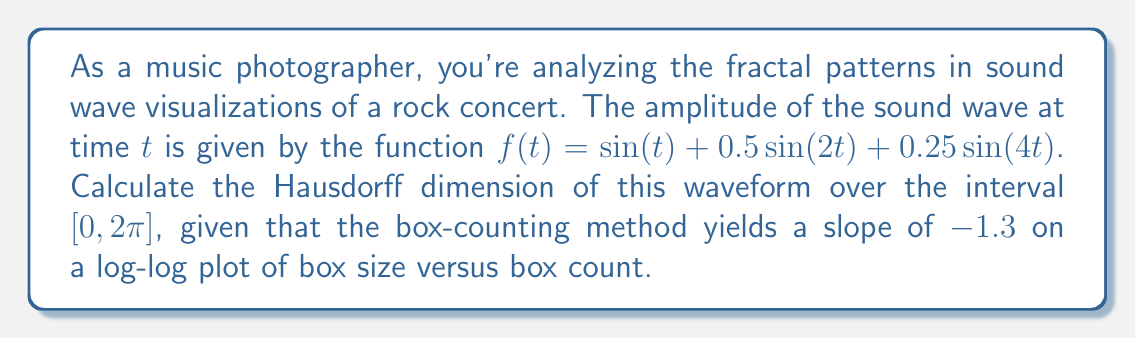What is the answer to this math problem? To determine the Hausdorff dimension of the sound wave visualization, we'll follow these steps:

1) The Hausdorff dimension is closely related to the box-counting dimension. In many cases, they are equivalent.

2) The box-counting dimension is defined as:

   $$D = -\lim_{\epsilon \to 0} \frac{\log N(\epsilon)}{\log \epsilon}$$

   where $N(\epsilon)$ is the number of boxes of size $\epsilon$ needed to cover the set.

3) In practice, this is often calculated by plotting $\log N(\epsilon)$ against $\log \epsilon$ and measuring the slope of the resulting line.

4) We're given that the slope of this log-log plot is $-1.3$. This negative slope is actually the negative of our dimension.

5) Therefore, the Hausdorff dimension $D$ is equal to the absolute value of this slope:

   $$D = |-1.3| = 1.3$$

This fractional dimension between 1 and 2 indicates that the sound wave visualization has a fractal nature, being more complex than a simple line (dimension 1) but not filling the plane (dimension 2).
Answer: 1.3 